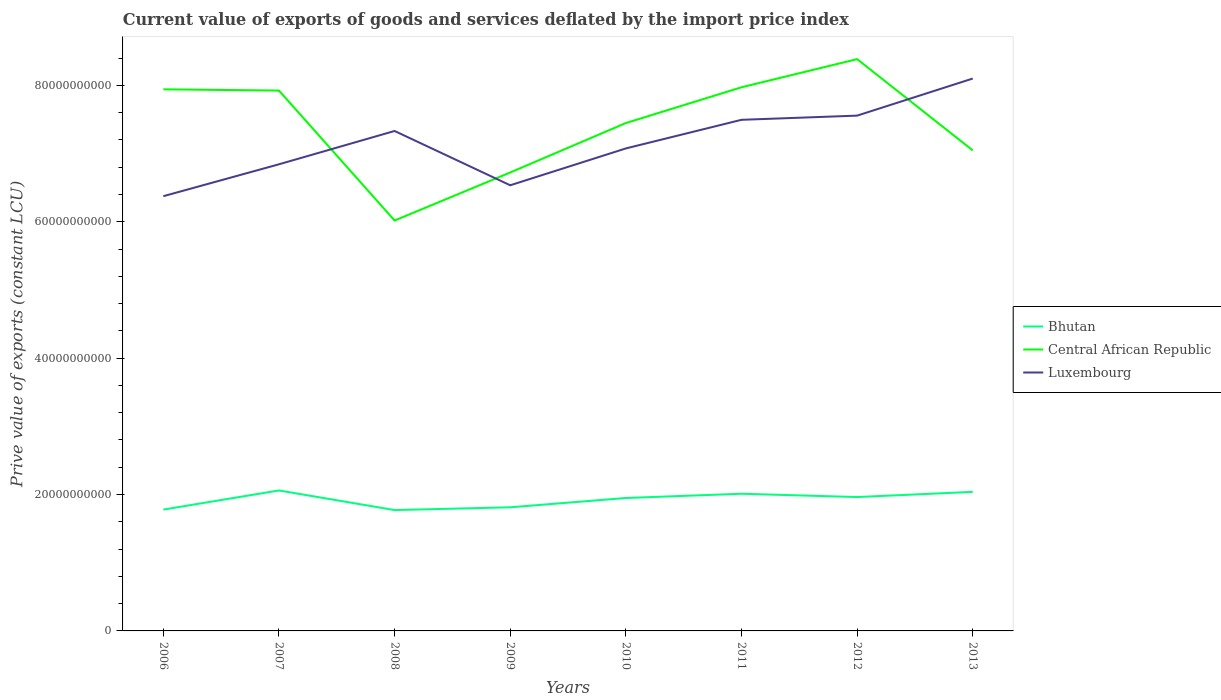How many different coloured lines are there?
Ensure brevity in your answer.  3. Does the line corresponding to Luxembourg intersect with the line corresponding to Bhutan?
Your answer should be very brief. No. Is the number of lines equal to the number of legend labels?
Provide a succinct answer. Yes. Across all years, what is the maximum prive value of exports in Bhutan?
Your response must be concise. 1.77e+1. In which year was the prive value of exports in Bhutan maximum?
Offer a terse response. 2008. What is the total prive value of exports in Central African Republic in the graph?
Ensure brevity in your answer.  -9.37e+09. What is the difference between the highest and the second highest prive value of exports in Bhutan?
Ensure brevity in your answer.  2.88e+09. What is the difference between the highest and the lowest prive value of exports in Bhutan?
Keep it short and to the point. 5. How many years are there in the graph?
Your answer should be very brief. 8. Are the values on the major ticks of Y-axis written in scientific E-notation?
Offer a very short reply. No. Does the graph contain any zero values?
Offer a terse response. No. Where does the legend appear in the graph?
Your answer should be compact. Center right. How many legend labels are there?
Keep it short and to the point. 3. What is the title of the graph?
Your answer should be very brief. Current value of exports of goods and services deflated by the import price index. What is the label or title of the X-axis?
Your answer should be very brief. Years. What is the label or title of the Y-axis?
Keep it short and to the point. Prive value of exports (constant LCU). What is the Prive value of exports (constant LCU) in Bhutan in 2006?
Provide a short and direct response. 1.78e+1. What is the Prive value of exports (constant LCU) of Central African Republic in 2006?
Provide a succinct answer. 7.94e+1. What is the Prive value of exports (constant LCU) in Luxembourg in 2006?
Your answer should be very brief. 6.37e+1. What is the Prive value of exports (constant LCU) of Bhutan in 2007?
Your answer should be compact. 2.06e+1. What is the Prive value of exports (constant LCU) in Central African Republic in 2007?
Make the answer very short. 7.92e+1. What is the Prive value of exports (constant LCU) of Luxembourg in 2007?
Your response must be concise. 6.84e+1. What is the Prive value of exports (constant LCU) in Bhutan in 2008?
Your answer should be compact. 1.77e+1. What is the Prive value of exports (constant LCU) of Central African Republic in 2008?
Keep it short and to the point. 6.02e+1. What is the Prive value of exports (constant LCU) of Luxembourg in 2008?
Your answer should be compact. 7.33e+1. What is the Prive value of exports (constant LCU) in Bhutan in 2009?
Give a very brief answer. 1.81e+1. What is the Prive value of exports (constant LCU) in Central African Republic in 2009?
Your answer should be compact. 6.72e+1. What is the Prive value of exports (constant LCU) in Luxembourg in 2009?
Your answer should be very brief. 6.54e+1. What is the Prive value of exports (constant LCU) of Bhutan in 2010?
Offer a terse response. 1.95e+1. What is the Prive value of exports (constant LCU) in Central African Republic in 2010?
Provide a short and direct response. 7.45e+1. What is the Prive value of exports (constant LCU) of Luxembourg in 2010?
Provide a succinct answer. 7.08e+1. What is the Prive value of exports (constant LCU) of Bhutan in 2011?
Your answer should be very brief. 2.01e+1. What is the Prive value of exports (constant LCU) of Central African Republic in 2011?
Keep it short and to the point. 7.97e+1. What is the Prive value of exports (constant LCU) of Luxembourg in 2011?
Make the answer very short. 7.50e+1. What is the Prive value of exports (constant LCU) in Bhutan in 2012?
Your answer should be very brief. 1.96e+1. What is the Prive value of exports (constant LCU) in Central African Republic in 2012?
Your answer should be compact. 8.39e+1. What is the Prive value of exports (constant LCU) in Luxembourg in 2012?
Your response must be concise. 7.56e+1. What is the Prive value of exports (constant LCU) of Bhutan in 2013?
Provide a short and direct response. 2.04e+1. What is the Prive value of exports (constant LCU) of Central African Republic in 2013?
Make the answer very short. 7.05e+1. What is the Prive value of exports (constant LCU) in Luxembourg in 2013?
Make the answer very short. 8.10e+1. Across all years, what is the maximum Prive value of exports (constant LCU) of Bhutan?
Provide a short and direct response. 2.06e+1. Across all years, what is the maximum Prive value of exports (constant LCU) in Central African Republic?
Offer a very short reply. 8.39e+1. Across all years, what is the maximum Prive value of exports (constant LCU) of Luxembourg?
Your answer should be very brief. 8.10e+1. Across all years, what is the minimum Prive value of exports (constant LCU) of Bhutan?
Your answer should be very brief. 1.77e+1. Across all years, what is the minimum Prive value of exports (constant LCU) of Central African Republic?
Your answer should be very brief. 6.02e+1. Across all years, what is the minimum Prive value of exports (constant LCU) of Luxembourg?
Make the answer very short. 6.37e+1. What is the total Prive value of exports (constant LCU) in Bhutan in the graph?
Offer a terse response. 1.54e+11. What is the total Prive value of exports (constant LCU) in Central African Republic in the graph?
Offer a terse response. 5.95e+11. What is the total Prive value of exports (constant LCU) in Luxembourg in the graph?
Ensure brevity in your answer.  5.73e+11. What is the difference between the Prive value of exports (constant LCU) of Bhutan in 2006 and that in 2007?
Make the answer very short. -2.81e+09. What is the difference between the Prive value of exports (constant LCU) in Central African Republic in 2006 and that in 2007?
Offer a terse response. 1.82e+08. What is the difference between the Prive value of exports (constant LCU) of Luxembourg in 2006 and that in 2007?
Make the answer very short. -4.68e+09. What is the difference between the Prive value of exports (constant LCU) in Bhutan in 2006 and that in 2008?
Offer a terse response. 7.04e+07. What is the difference between the Prive value of exports (constant LCU) of Central African Republic in 2006 and that in 2008?
Your answer should be compact. 1.92e+1. What is the difference between the Prive value of exports (constant LCU) of Luxembourg in 2006 and that in 2008?
Give a very brief answer. -9.56e+09. What is the difference between the Prive value of exports (constant LCU) of Bhutan in 2006 and that in 2009?
Offer a terse response. -3.35e+08. What is the difference between the Prive value of exports (constant LCU) in Central African Republic in 2006 and that in 2009?
Give a very brief answer. 1.22e+1. What is the difference between the Prive value of exports (constant LCU) in Luxembourg in 2006 and that in 2009?
Offer a very short reply. -1.60e+09. What is the difference between the Prive value of exports (constant LCU) of Bhutan in 2006 and that in 2010?
Your answer should be compact. -1.70e+09. What is the difference between the Prive value of exports (constant LCU) of Central African Republic in 2006 and that in 2010?
Ensure brevity in your answer.  4.94e+09. What is the difference between the Prive value of exports (constant LCU) in Luxembourg in 2006 and that in 2010?
Provide a short and direct response. -7.01e+09. What is the difference between the Prive value of exports (constant LCU) of Bhutan in 2006 and that in 2011?
Make the answer very short. -2.32e+09. What is the difference between the Prive value of exports (constant LCU) in Central African Republic in 2006 and that in 2011?
Make the answer very short. -3.00e+08. What is the difference between the Prive value of exports (constant LCU) of Luxembourg in 2006 and that in 2011?
Provide a succinct answer. -1.12e+1. What is the difference between the Prive value of exports (constant LCU) of Bhutan in 2006 and that in 2012?
Make the answer very short. -1.84e+09. What is the difference between the Prive value of exports (constant LCU) of Central African Republic in 2006 and that in 2012?
Provide a short and direct response. -4.43e+09. What is the difference between the Prive value of exports (constant LCU) in Luxembourg in 2006 and that in 2012?
Your answer should be very brief. -1.18e+1. What is the difference between the Prive value of exports (constant LCU) of Bhutan in 2006 and that in 2013?
Your response must be concise. -2.60e+09. What is the difference between the Prive value of exports (constant LCU) of Central African Republic in 2006 and that in 2013?
Make the answer very short. 8.95e+09. What is the difference between the Prive value of exports (constant LCU) of Luxembourg in 2006 and that in 2013?
Your response must be concise. -1.73e+1. What is the difference between the Prive value of exports (constant LCU) of Bhutan in 2007 and that in 2008?
Ensure brevity in your answer.  2.88e+09. What is the difference between the Prive value of exports (constant LCU) in Central African Republic in 2007 and that in 2008?
Ensure brevity in your answer.  1.91e+1. What is the difference between the Prive value of exports (constant LCU) of Luxembourg in 2007 and that in 2008?
Ensure brevity in your answer.  -4.89e+09. What is the difference between the Prive value of exports (constant LCU) in Bhutan in 2007 and that in 2009?
Your response must be concise. 2.47e+09. What is the difference between the Prive value of exports (constant LCU) in Central African Republic in 2007 and that in 2009?
Offer a very short reply. 1.20e+1. What is the difference between the Prive value of exports (constant LCU) in Luxembourg in 2007 and that in 2009?
Keep it short and to the point. 3.07e+09. What is the difference between the Prive value of exports (constant LCU) of Bhutan in 2007 and that in 2010?
Give a very brief answer. 1.11e+09. What is the difference between the Prive value of exports (constant LCU) in Central African Republic in 2007 and that in 2010?
Give a very brief answer. 4.76e+09. What is the difference between the Prive value of exports (constant LCU) of Luxembourg in 2007 and that in 2010?
Offer a terse response. -2.33e+09. What is the difference between the Prive value of exports (constant LCU) of Bhutan in 2007 and that in 2011?
Your answer should be very brief. 4.83e+08. What is the difference between the Prive value of exports (constant LCU) in Central African Republic in 2007 and that in 2011?
Offer a very short reply. -4.83e+08. What is the difference between the Prive value of exports (constant LCU) of Luxembourg in 2007 and that in 2011?
Provide a succinct answer. -6.52e+09. What is the difference between the Prive value of exports (constant LCU) in Bhutan in 2007 and that in 2012?
Offer a very short reply. 9.67e+08. What is the difference between the Prive value of exports (constant LCU) of Central African Republic in 2007 and that in 2012?
Offer a very short reply. -4.61e+09. What is the difference between the Prive value of exports (constant LCU) in Luxembourg in 2007 and that in 2012?
Offer a very short reply. -7.14e+09. What is the difference between the Prive value of exports (constant LCU) in Bhutan in 2007 and that in 2013?
Your answer should be very brief. 2.06e+08. What is the difference between the Prive value of exports (constant LCU) of Central African Republic in 2007 and that in 2013?
Offer a terse response. 8.77e+09. What is the difference between the Prive value of exports (constant LCU) of Luxembourg in 2007 and that in 2013?
Provide a succinct answer. -1.26e+1. What is the difference between the Prive value of exports (constant LCU) in Bhutan in 2008 and that in 2009?
Your answer should be very brief. -4.05e+08. What is the difference between the Prive value of exports (constant LCU) in Central African Republic in 2008 and that in 2009?
Offer a very short reply. -7.05e+09. What is the difference between the Prive value of exports (constant LCU) of Luxembourg in 2008 and that in 2009?
Your answer should be compact. 7.96e+09. What is the difference between the Prive value of exports (constant LCU) of Bhutan in 2008 and that in 2010?
Keep it short and to the point. -1.77e+09. What is the difference between the Prive value of exports (constant LCU) of Central African Republic in 2008 and that in 2010?
Give a very brief answer. -1.43e+1. What is the difference between the Prive value of exports (constant LCU) in Luxembourg in 2008 and that in 2010?
Make the answer very short. 2.56e+09. What is the difference between the Prive value of exports (constant LCU) of Bhutan in 2008 and that in 2011?
Provide a succinct answer. -2.39e+09. What is the difference between the Prive value of exports (constant LCU) of Central African Republic in 2008 and that in 2011?
Your answer should be compact. -1.95e+1. What is the difference between the Prive value of exports (constant LCU) of Luxembourg in 2008 and that in 2011?
Make the answer very short. -1.64e+09. What is the difference between the Prive value of exports (constant LCU) of Bhutan in 2008 and that in 2012?
Your answer should be very brief. -1.91e+09. What is the difference between the Prive value of exports (constant LCU) of Central African Republic in 2008 and that in 2012?
Provide a succinct answer. -2.37e+1. What is the difference between the Prive value of exports (constant LCU) of Luxembourg in 2008 and that in 2012?
Ensure brevity in your answer.  -2.25e+09. What is the difference between the Prive value of exports (constant LCU) of Bhutan in 2008 and that in 2013?
Offer a very short reply. -2.67e+09. What is the difference between the Prive value of exports (constant LCU) of Central African Republic in 2008 and that in 2013?
Make the answer very short. -1.03e+1. What is the difference between the Prive value of exports (constant LCU) in Luxembourg in 2008 and that in 2013?
Offer a very short reply. -7.69e+09. What is the difference between the Prive value of exports (constant LCU) in Bhutan in 2009 and that in 2010?
Your response must be concise. -1.36e+09. What is the difference between the Prive value of exports (constant LCU) in Central African Republic in 2009 and that in 2010?
Offer a terse response. -7.25e+09. What is the difference between the Prive value of exports (constant LCU) of Luxembourg in 2009 and that in 2010?
Your answer should be compact. -5.40e+09. What is the difference between the Prive value of exports (constant LCU) in Bhutan in 2009 and that in 2011?
Offer a terse response. -1.99e+09. What is the difference between the Prive value of exports (constant LCU) of Central African Republic in 2009 and that in 2011?
Provide a succinct answer. -1.25e+1. What is the difference between the Prive value of exports (constant LCU) of Luxembourg in 2009 and that in 2011?
Your answer should be compact. -9.60e+09. What is the difference between the Prive value of exports (constant LCU) of Bhutan in 2009 and that in 2012?
Provide a succinct answer. -1.50e+09. What is the difference between the Prive value of exports (constant LCU) of Central African Republic in 2009 and that in 2012?
Offer a terse response. -1.66e+1. What is the difference between the Prive value of exports (constant LCU) in Luxembourg in 2009 and that in 2012?
Keep it short and to the point. -1.02e+1. What is the difference between the Prive value of exports (constant LCU) in Bhutan in 2009 and that in 2013?
Offer a terse response. -2.26e+09. What is the difference between the Prive value of exports (constant LCU) in Central African Republic in 2009 and that in 2013?
Give a very brief answer. -3.24e+09. What is the difference between the Prive value of exports (constant LCU) in Luxembourg in 2009 and that in 2013?
Your response must be concise. -1.56e+1. What is the difference between the Prive value of exports (constant LCU) in Bhutan in 2010 and that in 2011?
Provide a short and direct response. -6.25e+08. What is the difference between the Prive value of exports (constant LCU) in Central African Republic in 2010 and that in 2011?
Provide a short and direct response. -5.24e+09. What is the difference between the Prive value of exports (constant LCU) of Luxembourg in 2010 and that in 2011?
Your response must be concise. -4.20e+09. What is the difference between the Prive value of exports (constant LCU) in Bhutan in 2010 and that in 2012?
Provide a short and direct response. -1.41e+08. What is the difference between the Prive value of exports (constant LCU) of Central African Republic in 2010 and that in 2012?
Offer a terse response. -9.37e+09. What is the difference between the Prive value of exports (constant LCU) in Luxembourg in 2010 and that in 2012?
Your answer should be very brief. -4.81e+09. What is the difference between the Prive value of exports (constant LCU) in Bhutan in 2010 and that in 2013?
Ensure brevity in your answer.  -9.02e+08. What is the difference between the Prive value of exports (constant LCU) of Central African Republic in 2010 and that in 2013?
Give a very brief answer. 4.01e+09. What is the difference between the Prive value of exports (constant LCU) of Luxembourg in 2010 and that in 2013?
Your response must be concise. -1.02e+1. What is the difference between the Prive value of exports (constant LCU) in Bhutan in 2011 and that in 2012?
Offer a terse response. 4.83e+08. What is the difference between the Prive value of exports (constant LCU) of Central African Republic in 2011 and that in 2012?
Ensure brevity in your answer.  -4.13e+09. What is the difference between the Prive value of exports (constant LCU) in Luxembourg in 2011 and that in 2012?
Provide a short and direct response. -6.13e+08. What is the difference between the Prive value of exports (constant LCU) in Bhutan in 2011 and that in 2013?
Your answer should be very brief. -2.77e+08. What is the difference between the Prive value of exports (constant LCU) of Central African Republic in 2011 and that in 2013?
Provide a short and direct response. 9.25e+09. What is the difference between the Prive value of exports (constant LCU) of Luxembourg in 2011 and that in 2013?
Provide a succinct answer. -6.05e+09. What is the difference between the Prive value of exports (constant LCU) in Bhutan in 2012 and that in 2013?
Make the answer very short. -7.60e+08. What is the difference between the Prive value of exports (constant LCU) of Central African Republic in 2012 and that in 2013?
Provide a succinct answer. 1.34e+1. What is the difference between the Prive value of exports (constant LCU) of Luxembourg in 2012 and that in 2013?
Offer a terse response. -5.44e+09. What is the difference between the Prive value of exports (constant LCU) of Bhutan in 2006 and the Prive value of exports (constant LCU) of Central African Republic in 2007?
Provide a short and direct response. -6.14e+1. What is the difference between the Prive value of exports (constant LCU) in Bhutan in 2006 and the Prive value of exports (constant LCU) in Luxembourg in 2007?
Your answer should be compact. -5.06e+1. What is the difference between the Prive value of exports (constant LCU) in Central African Republic in 2006 and the Prive value of exports (constant LCU) in Luxembourg in 2007?
Make the answer very short. 1.10e+1. What is the difference between the Prive value of exports (constant LCU) of Bhutan in 2006 and the Prive value of exports (constant LCU) of Central African Republic in 2008?
Your answer should be compact. -4.24e+1. What is the difference between the Prive value of exports (constant LCU) of Bhutan in 2006 and the Prive value of exports (constant LCU) of Luxembourg in 2008?
Provide a succinct answer. -5.55e+1. What is the difference between the Prive value of exports (constant LCU) in Central African Republic in 2006 and the Prive value of exports (constant LCU) in Luxembourg in 2008?
Ensure brevity in your answer.  6.11e+09. What is the difference between the Prive value of exports (constant LCU) in Bhutan in 2006 and the Prive value of exports (constant LCU) in Central African Republic in 2009?
Offer a terse response. -4.94e+1. What is the difference between the Prive value of exports (constant LCU) of Bhutan in 2006 and the Prive value of exports (constant LCU) of Luxembourg in 2009?
Make the answer very short. -4.76e+1. What is the difference between the Prive value of exports (constant LCU) of Central African Republic in 2006 and the Prive value of exports (constant LCU) of Luxembourg in 2009?
Your answer should be compact. 1.41e+1. What is the difference between the Prive value of exports (constant LCU) of Bhutan in 2006 and the Prive value of exports (constant LCU) of Central African Republic in 2010?
Make the answer very short. -5.67e+1. What is the difference between the Prive value of exports (constant LCU) in Bhutan in 2006 and the Prive value of exports (constant LCU) in Luxembourg in 2010?
Keep it short and to the point. -5.30e+1. What is the difference between the Prive value of exports (constant LCU) in Central African Republic in 2006 and the Prive value of exports (constant LCU) in Luxembourg in 2010?
Your answer should be compact. 8.67e+09. What is the difference between the Prive value of exports (constant LCU) in Bhutan in 2006 and the Prive value of exports (constant LCU) in Central African Republic in 2011?
Give a very brief answer. -6.19e+1. What is the difference between the Prive value of exports (constant LCU) of Bhutan in 2006 and the Prive value of exports (constant LCU) of Luxembourg in 2011?
Your answer should be compact. -5.72e+1. What is the difference between the Prive value of exports (constant LCU) in Central African Republic in 2006 and the Prive value of exports (constant LCU) in Luxembourg in 2011?
Your response must be concise. 4.47e+09. What is the difference between the Prive value of exports (constant LCU) in Bhutan in 2006 and the Prive value of exports (constant LCU) in Central African Republic in 2012?
Provide a succinct answer. -6.61e+1. What is the difference between the Prive value of exports (constant LCU) in Bhutan in 2006 and the Prive value of exports (constant LCU) in Luxembourg in 2012?
Provide a short and direct response. -5.78e+1. What is the difference between the Prive value of exports (constant LCU) of Central African Republic in 2006 and the Prive value of exports (constant LCU) of Luxembourg in 2012?
Provide a succinct answer. 3.86e+09. What is the difference between the Prive value of exports (constant LCU) of Bhutan in 2006 and the Prive value of exports (constant LCU) of Central African Republic in 2013?
Offer a very short reply. -5.27e+1. What is the difference between the Prive value of exports (constant LCU) of Bhutan in 2006 and the Prive value of exports (constant LCU) of Luxembourg in 2013?
Your response must be concise. -6.32e+1. What is the difference between the Prive value of exports (constant LCU) of Central African Republic in 2006 and the Prive value of exports (constant LCU) of Luxembourg in 2013?
Your answer should be compact. -1.58e+09. What is the difference between the Prive value of exports (constant LCU) in Bhutan in 2007 and the Prive value of exports (constant LCU) in Central African Republic in 2008?
Offer a terse response. -3.96e+1. What is the difference between the Prive value of exports (constant LCU) of Bhutan in 2007 and the Prive value of exports (constant LCU) of Luxembourg in 2008?
Give a very brief answer. -5.27e+1. What is the difference between the Prive value of exports (constant LCU) in Central African Republic in 2007 and the Prive value of exports (constant LCU) in Luxembourg in 2008?
Make the answer very short. 5.93e+09. What is the difference between the Prive value of exports (constant LCU) of Bhutan in 2007 and the Prive value of exports (constant LCU) of Central African Republic in 2009?
Provide a succinct answer. -4.66e+1. What is the difference between the Prive value of exports (constant LCU) in Bhutan in 2007 and the Prive value of exports (constant LCU) in Luxembourg in 2009?
Offer a terse response. -4.48e+1. What is the difference between the Prive value of exports (constant LCU) of Central African Republic in 2007 and the Prive value of exports (constant LCU) of Luxembourg in 2009?
Make the answer very short. 1.39e+1. What is the difference between the Prive value of exports (constant LCU) in Bhutan in 2007 and the Prive value of exports (constant LCU) in Central African Republic in 2010?
Offer a very short reply. -5.39e+1. What is the difference between the Prive value of exports (constant LCU) in Bhutan in 2007 and the Prive value of exports (constant LCU) in Luxembourg in 2010?
Provide a short and direct response. -5.02e+1. What is the difference between the Prive value of exports (constant LCU) of Central African Republic in 2007 and the Prive value of exports (constant LCU) of Luxembourg in 2010?
Your response must be concise. 8.49e+09. What is the difference between the Prive value of exports (constant LCU) in Bhutan in 2007 and the Prive value of exports (constant LCU) in Central African Republic in 2011?
Give a very brief answer. -5.91e+1. What is the difference between the Prive value of exports (constant LCU) in Bhutan in 2007 and the Prive value of exports (constant LCU) in Luxembourg in 2011?
Offer a very short reply. -5.44e+1. What is the difference between the Prive value of exports (constant LCU) in Central African Republic in 2007 and the Prive value of exports (constant LCU) in Luxembourg in 2011?
Offer a terse response. 4.29e+09. What is the difference between the Prive value of exports (constant LCU) in Bhutan in 2007 and the Prive value of exports (constant LCU) in Central African Republic in 2012?
Provide a short and direct response. -6.33e+1. What is the difference between the Prive value of exports (constant LCU) of Bhutan in 2007 and the Prive value of exports (constant LCU) of Luxembourg in 2012?
Provide a short and direct response. -5.50e+1. What is the difference between the Prive value of exports (constant LCU) of Central African Republic in 2007 and the Prive value of exports (constant LCU) of Luxembourg in 2012?
Offer a terse response. 3.68e+09. What is the difference between the Prive value of exports (constant LCU) of Bhutan in 2007 and the Prive value of exports (constant LCU) of Central African Republic in 2013?
Your answer should be compact. -4.99e+1. What is the difference between the Prive value of exports (constant LCU) of Bhutan in 2007 and the Prive value of exports (constant LCU) of Luxembourg in 2013?
Your answer should be very brief. -6.04e+1. What is the difference between the Prive value of exports (constant LCU) in Central African Republic in 2007 and the Prive value of exports (constant LCU) in Luxembourg in 2013?
Provide a short and direct response. -1.76e+09. What is the difference between the Prive value of exports (constant LCU) of Bhutan in 2008 and the Prive value of exports (constant LCU) of Central African Republic in 2009?
Your response must be concise. -4.95e+1. What is the difference between the Prive value of exports (constant LCU) in Bhutan in 2008 and the Prive value of exports (constant LCU) in Luxembourg in 2009?
Provide a short and direct response. -4.76e+1. What is the difference between the Prive value of exports (constant LCU) of Central African Republic in 2008 and the Prive value of exports (constant LCU) of Luxembourg in 2009?
Ensure brevity in your answer.  -5.17e+09. What is the difference between the Prive value of exports (constant LCU) in Bhutan in 2008 and the Prive value of exports (constant LCU) in Central African Republic in 2010?
Provide a short and direct response. -5.68e+1. What is the difference between the Prive value of exports (constant LCU) in Bhutan in 2008 and the Prive value of exports (constant LCU) in Luxembourg in 2010?
Offer a terse response. -5.30e+1. What is the difference between the Prive value of exports (constant LCU) in Central African Republic in 2008 and the Prive value of exports (constant LCU) in Luxembourg in 2010?
Make the answer very short. -1.06e+1. What is the difference between the Prive value of exports (constant LCU) in Bhutan in 2008 and the Prive value of exports (constant LCU) in Central African Republic in 2011?
Your answer should be very brief. -6.20e+1. What is the difference between the Prive value of exports (constant LCU) in Bhutan in 2008 and the Prive value of exports (constant LCU) in Luxembourg in 2011?
Make the answer very short. -5.72e+1. What is the difference between the Prive value of exports (constant LCU) of Central African Republic in 2008 and the Prive value of exports (constant LCU) of Luxembourg in 2011?
Offer a very short reply. -1.48e+1. What is the difference between the Prive value of exports (constant LCU) in Bhutan in 2008 and the Prive value of exports (constant LCU) in Central African Republic in 2012?
Offer a terse response. -6.61e+1. What is the difference between the Prive value of exports (constant LCU) of Bhutan in 2008 and the Prive value of exports (constant LCU) of Luxembourg in 2012?
Give a very brief answer. -5.78e+1. What is the difference between the Prive value of exports (constant LCU) in Central African Republic in 2008 and the Prive value of exports (constant LCU) in Luxembourg in 2012?
Your answer should be very brief. -1.54e+1. What is the difference between the Prive value of exports (constant LCU) of Bhutan in 2008 and the Prive value of exports (constant LCU) of Central African Republic in 2013?
Offer a terse response. -5.27e+1. What is the difference between the Prive value of exports (constant LCU) in Bhutan in 2008 and the Prive value of exports (constant LCU) in Luxembourg in 2013?
Your answer should be compact. -6.33e+1. What is the difference between the Prive value of exports (constant LCU) in Central African Republic in 2008 and the Prive value of exports (constant LCU) in Luxembourg in 2013?
Your response must be concise. -2.08e+1. What is the difference between the Prive value of exports (constant LCU) of Bhutan in 2009 and the Prive value of exports (constant LCU) of Central African Republic in 2010?
Provide a succinct answer. -5.64e+1. What is the difference between the Prive value of exports (constant LCU) of Bhutan in 2009 and the Prive value of exports (constant LCU) of Luxembourg in 2010?
Offer a terse response. -5.26e+1. What is the difference between the Prive value of exports (constant LCU) in Central African Republic in 2009 and the Prive value of exports (constant LCU) in Luxembourg in 2010?
Your answer should be compact. -3.53e+09. What is the difference between the Prive value of exports (constant LCU) in Bhutan in 2009 and the Prive value of exports (constant LCU) in Central African Republic in 2011?
Make the answer very short. -6.16e+1. What is the difference between the Prive value of exports (constant LCU) in Bhutan in 2009 and the Prive value of exports (constant LCU) in Luxembourg in 2011?
Your answer should be very brief. -5.68e+1. What is the difference between the Prive value of exports (constant LCU) of Central African Republic in 2009 and the Prive value of exports (constant LCU) of Luxembourg in 2011?
Your answer should be very brief. -7.72e+09. What is the difference between the Prive value of exports (constant LCU) of Bhutan in 2009 and the Prive value of exports (constant LCU) of Central African Republic in 2012?
Your response must be concise. -6.57e+1. What is the difference between the Prive value of exports (constant LCU) of Bhutan in 2009 and the Prive value of exports (constant LCU) of Luxembourg in 2012?
Ensure brevity in your answer.  -5.74e+1. What is the difference between the Prive value of exports (constant LCU) of Central African Republic in 2009 and the Prive value of exports (constant LCU) of Luxembourg in 2012?
Your response must be concise. -8.34e+09. What is the difference between the Prive value of exports (constant LCU) of Bhutan in 2009 and the Prive value of exports (constant LCU) of Central African Republic in 2013?
Your answer should be very brief. -5.23e+1. What is the difference between the Prive value of exports (constant LCU) in Bhutan in 2009 and the Prive value of exports (constant LCU) in Luxembourg in 2013?
Provide a succinct answer. -6.29e+1. What is the difference between the Prive value of exports (constant LCU) in Central African Republic in 2009 and the Prive value of exports (constant LCU) in Luxembourg in 2013?
Keep it short and to the point. -1.38e+1. What is the difference between the Prive value of exports (constant LCU) in Bhutan in 2010 and the Prive value of exports (constant LCU) in Central African Republic in 2011?
Provide a succinct answer. -6.02e+1. What is the difference between the Prive value of exports (constant LCU) in Bhutan in 2010 and the Prive value of exports (constant LCU) in Luxembourg in 2011?
Your response must be concise. -5.55e+1. What is the difference between the Prive value of exports (constant LCU) of Central African Republic in 2010 and the Prive value of exports (constant LCU) of Luxembourg in 2011?
Keep it short and to the point. -4.73e+08. What is the difference between the Prive value of exports (constant LCU) in Bhutan in 2010 and the Prive value of exports (constant LCU) in Central African Republic in 2012?
Offer a very short reply. -6.44e+1. What is the difference between the Prive value of exports (constant LCU) in Bhutan in 2010 and the Prive value of exports (constant LCU) in Luxembourg in 2012?
Your answer should be very brief. -5.61e+1. What is the difference between the Prive value of exports (constant LCU) of Central African Republic in 2010 and the Prive value of exports (constant LCU) of Luxembourg in 2012?
Offer a very short reply. -1.09e+09. What is the difference between the Prive value of exports (constant LCU) of Bhutan in 2010 and the Prive value of exports (constant LCU) of Central African Republic in 2013?
Provide a succinct answer. -5.10e+1. What is the difference between the Prive value of exports (constant LCU) of Bhutan in 2010 and the Prive value of exports (constant LCU) of Luxembourg in 2013?
Ensure brevity in your answer.  -6.15e+1. What is the difference between the Prive value of exports (constant LCU) in Central African Republic in 2010 and the Prive value of exports (constant LCU) in Luxembourg in 2013?
Your answer should be compact. -6.52e+09. What is the difference between the Prive value of exports (constant LCU) in Bhutan in 2011 and the Prive value of exports (constant LCU) in Central African Republic in 2012?
Your answer should be very brief. -6.37e+1. What is the difference between the Prive value of exports (constant LCU) of Bhutan in 2011 and the Prive value of exports (constant LCU) of Luxembourg in 2012?
Offer a terse response. -5.54e+1. What is the difference between the Prive value of exports (constant LCU) of Central African Republic in 2011 and the Prive value of exports (constant LCU) of Luxembourg in 2012?
Give a very brief answer. 4.16e+09. What is the difference between the Prive value of exports (constant LCU) in Bhutan in 2011 and the Prive value of exports (constant LCU) in Central African Republic in 2013?
Ensure brevity in your answer.  -5.04e+1. What is the difference between the Prive value of exports (constant LCU) of Bhutan in 2011 and the Prive value of exports (constant LCU) of Luxembourg in 2013?
Your answer should be very brief. -6.09e+1. What is the difference between the Prive value of exports (constant LCU) of Central African Republic in 2011 and the Prive value of exports (constant LCU) of Luxembourg in 2013?
Give a very brief answer. -1.28e+09. What is the difference between the Prive value of exports (constant LCU) of Bhutan in 2012 and the Prive value of exports (constant LCU) of Central African Republic in 2013?
Your answer should be very brief. -5.08e+1. What is the difference between the Prive value of exports (constant LCU) in Bhutan in 2012 and the Prive value of exports (constant LCU) in Luxembourg in 2013?
Provide a short and direct response. -6.14e+1. What is the difference between the Prive value of exports (constant LCU) in Central African Republic in 2012 and the Prive value of exports (constant LCU) in Luxembourg in 2013?
Your answer should be very brief. 2.85e+09. What is the average Prive value of exports (constant LCU) of Bhutan per year?
Provide a succinct answer. 1.92e+1. What is the average Prive value of exports (constant LCU) of Central African Republic per year?
Provide a succinct answer. 7.43e+1. What is the average Prive value of exports (constant LCU) of Luxembourg per year?
Ensure brevity in your answer.  7.16e+1. In the year 2006, what is the difference between the Prive value of exports (constant LCU) in Bhutan and Prive value of exports (constant LCU) in Central African Republic?
Keep it short and to the point. -6.16e+1. In the year 2006, what is the difference between the Prive value of exports (constant LCU) in Bhutan and Prive value of exports (constant LCU) in Luxembourg?
Offer a terse response. -4.60e+1. In the year 2006, what is the difference between the Prive value of exports (constant LCU) in Central African Republic and Prive value of exports (constant LCU) in Luxembourg?
Make the answer very short. 1.57e+1. In the year 2007, what is the difference between the Prive value of exports (constant LCU) in Bhutan and Prive value of exports (constant LCU) in Central African Republic?
Provide a short and direct response. -5.86e+1. In the year 2007, what is the difference between the Prive value of exports (constant LCU) in Bhutan and Prive value of exports (constant LCU) in Luxembourg?
Ensure brevity in your answer.  -4.78e+1. In the year 2007, what is the difference between the Prive value of exports (constant LCU) of Central African Republic and Prive value of exports (constant LCU) of Luxembourg?
Your answer should be compact. 1.08e+1. In the year 2008, what is the difference between the Prive value of exports (constant LCU) of Bhutan and Prive value of exports (constant LCU) of Central African Republic?
Provide a short and direct response. -4.25e+1. In the year 2008, what is the difference between the Prive value of exports (constant LCU) of Bhutan and Prive value of exports (constant LCU) of Luxembourg?
Your answer should be very brief. -5.56e+1. In the year 2008, what is the difference between the Prive value of exports (constant LCU) of Central African Republic and Prive value of exports (constant LCU) of Luxembourg?
Make the answer very short. -1.31e+1. In the year 2009, what is the difference between the Prive value of exports (constant LCU) in Bhutan and Prive value of exports (constant LCU) in Central African Republic?
Provide a succinct answer. -4.91e+1. In the year 2009, what is the difference between the Prive value of exports (constant LCU) in Bhutan and Prive value of exports (constant LCU) in Luxembourg?
Make the answer very short. -4.72e+1. In the year 2009, what is the difference between the Prive value of exports (constant LCU) in Central African Republic and Prive value of exports (constant LCU) in Luxembourg?
Your response must be concise. 1.87e+09. In the year 2010, what is the difference between the Prive value of exports (constant LCU) in Bhutan and Prive value of exports (constant LCU) in Central African Republic?
Keep it short and to the point. -5.50e+1. In the year 2010, what is the difference between the Prive value of exports (constant LCU) in Bhutan and Prive value of exports (constant LCU) in Luxembourg?
Your answer should be very brief. -5.13e+1. In the year 2010, what is the difference between the Prive value of exports (constant LCU) in Central African Republic and Prive value of exports (constant LCU) in Luxembourg?
Provide a succinct answer. 3.72e+09. In the year 2011, what is the difference between the Prive value of exports (constant LCU) of Bhutan and Prive value of exports (constant LCU) of Central African Republic?
Your answer should be very brief. -5.96e+1. In the year 2011, what is the difference between the Prive value of exports (constant LCU) in Bhutan and Prive value of exports (constant LCU) in Luxembourg?
Keep it short and to the point. -5.48e+1. In the year 2011, what is the difference between the Prive value of exports (constant LCU) of Central African Republic and Prive value of exports (constant LCU) of Luxembourg?
Your answer should be very brief. 4.77e+09. In the year 2012, what is the difference between the Prive value of exports (constant LCU) of Bhutan and Prive value of exports (constant LCU) of Central African Republic?
Make the answer very short. -6.42e+1. In the year 2012, what is the difference between the Prive value of exports (constant LCU) of Bhutan and Prive value of exports (constant LCU) of Luxembourg?
Ensure brevity in your answer.  -5.59e+1. In the year 2012, what is the difference between the Prive value of exports (constant LCU) in Central African Republic and Prive value of exports (constant LCU) in Luxembourg?
Keep it short and to the point. 8.29e+09. In the year 2013, what is the difference between the Prive value of exports (constant LCU) in Bhutan and Prive value of exports (constant LCU) in Central African Republic?
Your answer should be compact. -5.01e+1. In the year 2013, what is the difference between the Prive value of exports (constant LCU) of Bhutan and Prive value of exports (constant LCU) of Luxembourg?
Offer a terse response. -6.06e+1. In the year 2013, what is the difference between the Prive value of exports (constant LCU) in Central African Republic and Prive value of exports (constant LCU) in Luxembourg?
Offer a terse response. -1.05e+1. What is the ratio of the Prive value of exports (constant LCU) in Bhutan in 2006 to that in 2007?
Your response must be concise. 0.86. What is the ratio of the Prive value of exports (constant LCU) of Central African Republic in 2006 to that in 2007?
Keep it short and to the point. 1. What is the ratio of the Prive value of exports (constant LCU) in Luxembourg in 2006 to that in 2007?
Ensure brevity in your answer.  0.93. What is the ratio of the Prive value of exports (constant LCU) of Central African Republic in 2006 to that in 2008?
Offer a very short reply. 1.32. What is the ratio of the Prive value of exports (constant LCU) in Luxembourg in 2006 to that in 2008?
Ensure brevity in your answer.  0.87. What is the ratio of the Prive value of exports (constant LCU) of Bhutan in 2006 to that in 2009?
Keep it short and to the point. 0.98. What is the ratio of the Prive value of exports (constant LCU) of Central African Republic in 2006 to that in 2009?
Provide a succinct answer. 1.18. What is the ratio of the Prive value of exports (constant LCU) of Luxembourg in 2006 to that in 2009?
Your answer should be very brief. 0.98. What is the ratio of the Prive value of exports (constant LCU) in Bhutan in 2006 to that in 2010?
Ensure brevity in your answer.  0.91. What is the ratio of the Prive value of exports (constant LCU) in Central African Republic in 2006 to that in 2010?
Keep it short and to the point. 1.07. What is the ratio of the Prive value of exports (constant LCU) of Luxembourg in 2006 to that in 2010?
Ensure brevity in your answer.  0.9. What is the ratio of the Prive value of exports (constant LCU) of Bhutan in 2006 to that in 2011?
Offer a very short reply. 0.88. What is the ratio of the Prive value of exports (constant LCU) of Luxembourg in 2006 to that in 2011?
Provide a short and direct response. 0.85. What is the ratio of the Prive value of exports (constant LCU) in Bhutan in 2006 to that in 2012?
Make the answer very short. 0.91. What is the ratio of the Prive value of exports (constant LCU) in Central African Republic in 2006 to that in 2012?
Your answer should be compact. 0.95. What is the ratio of the Prive value of exports (constant LCU) in Luxembourg in 2006 to that in 2012?
Make the answer very short. 0.84. What is the ratio of the Prive value of exports (constant LCU) in Bhutan in 2006 to that in 2013?
Provide a short and direct response. 0.87. What is the ratio of the Prive value of exports (constant LCU) in Central African Republic in 2006 to that in 2013?
Keep it short and to the point. 1.13. What is the ratio of the Prive value of exports (constant LCU) in Luxembourg in 2006 to that in 2013?
Keep it short and to the point. 0.79. What is the ratio of the Prive value of exports (constant LCU) of Bhutan in 2007 to that in 2008?
Provide a succinct answer. 1.16. What is the ratio of the Prive value of exports (constant LCU) of Central African Republic in 2007 to that in 2008?
Make the answer very short. 1.32. What is the ratio of the Prive value of exports (constant LCU) in Luxembourg in 2007 to that in 2008?
Give a very brief answer. 0.93. What is the ratio of the Prive value of exports (constant LCU) in Bhutan in 2007 to that in 2009?
Provide a succinct answer. 1.14. What is the ratio of the Prive value of exports (constant LCU) in Central African Republic in 2007 to that in 2009?
Provide a short and direct response. 1.18. What is the ratio of the Prive value of exports (constant LCU) of Luxembourg in 2007 to that in 2009?
Your answer should be very brief. 1.05. What is the ratio of the Prive value of exports (constant LCU) of Bhutan in 2007 to that in 2010?
Offer a very short reply. 1.06. What is the ratio of the Prive value of exports (constant LCU) of Central African Republic in 2007 to that in 2010?
Keep it short and to the point. 1.06. What is the ratio of the Prive value of exports (constant LCU) of Luxembourg in 2007 to that in 2010?
Keep it short and to the point. 0.97. What is the ratio of the Prive value of exports (constant LCU) of Luxembourg in 2007 to that in 2011?
Ensure brevity in your answer.  0.91. What is the ratio of the Prive value of exports (constant LCU) of Bhutan in 2007 to that in 2012?
Give a very brief answer. 1.05. What is the ratio of the Prive value of exports (constant LCU) in Central African Republic in 2007 to that in 2012?
Give a very brief answer. 0.94. What is the ratio of the Prive value of exports (constant LCU) in Luxembourg in 2007 to that in 2012?
Make the answer very short. 0.91. What is the ratio of the Prive value of exports (constant LCU) in Central African Republic in 2007 to that in 2013?
Offer a terse response. 1.12. What is the ratio of the Prive value of exports (constant LCU) of Luxembourg in 2007 to that in 2013?
Your response must be concise. 0.84. What is the ratio of the Prive value of exports (constant LCU) in Bhutan in 2008 to that in 2009?
Make the answer very short. 0.98. What is the ratio of the Prive value of exports (constant LCU) of Central African Republic in 2008 to that in 2009?
Give a very brief answer. 0.9. What is the ratio of the Prive value of exports (constant LCU) in Luxembourg in 2008 to that in 2009?
Offer a very short reply. 1.12. What is the ratio of the Prive value of exports (constant LCU) of Bhutan in 2008 to that in 2010?
Offer a very short reply. 0.91. What is the ratio of the Prive value of exports (constant LCU) of Central African Republic in 2008 to that in 2010?
Offer a terse response. 0.81. What is the ratio of the Prive value of exports (constant LCU) in Luxembourg in 2008 to that in 2010?
Ensure brevity in your answer.  1.04. What is the ratio of the Prive value of exports (constant LCU) of Bhutan in 2008 to that in 2011?
Ensure brevity in your answer.  0.88. What is the ratio of the Prive value of exports (constant LCU) in Central African Republic in 2008 to that in 2011?
Ensure brevity in your answer.  0.75. What is the ratio of the Prive value of exports (constant LCU) in Luxembourg in 2008 to that in 2011?
Your answer should be compact. 0.98. What is the ratio of the Prive value of exports (constant LCU) in Bhutan in 2008 to that in 2012?
Provide a short and direct response. 0.9. What is the ratio of the Prive value of exports (constant LCU) in Central African Republic in 2008 to that in 2012?
Provide a succinct answer. 0.72. What is the ratio of the Prive value of exports (constant LCU) in Luxembourg in 2008 to that in 2012?
Ensure brevity in your answer.  0.97. What is the ratio of the Prive value of exports (constant LCU) of Bhutan in 2008 to that in 2013?
Give a very brief answer. 0.87. What is the ratio of the Prive value of exports (constant LCU) in Central African Republic in 2008 to that in 2013?
Make the answer very short. 0.85. What is the ratio of the Prive value of exports (constant LCU) in Luxembourg in 2008 to that in 2013?
Your answer should be compact. 0.91. What is the ratio of the Prive value of exports (constant LCU) in Bhutan in 2009 to that in 2010?
Make the answer very short. 0.93. What is the ratio of the Prive value of exports (constant LCU) in Central African Republic in 2009 to that in 2010?
Make the answer very short. 0.9. What is the ratio of the Prive value of exports (constant LCU) of Luxembourg in 2009 to that in 2010?
Keep it short and to the point. 0.92. What is the ratio of the Prive value of exports (constant LCU) in Bhutan in 2009 to that in 2011?
Ensure brevity in your answer.  0.9. What is the ratio of the Prive value of exports (constant LCU) of Central African Republic in 2009 to that in 2011?
Your response must be concise. 0.84. What is the ratio of the Prive value of exports (constant LCU) of Luxembourg in 2009 to that in 2011?
Make the answer very short. 0.87. What is the ratio of the Prive value of exports (constant LCU) of Bhutan in 2009 to that in 2012?
Provide a succinct answer. 0.92. What is the ratio of the Prive value of exports (constant LCU) in Central African Republic in 2009 to that in 2012?
Keep it short and to the point. 0.8. What is the ratio of the Prive value of exports (constant LCU) of Luxembourg in 2009 to that in 2012?
Offer a terse response. 0.86. What is the ratio of the Prive value of exports (constant LCU) of Central African Republic in 2009 to that in 2013?
Make the answer very short. 0.95. What is the ratio of the Prive value of exports (constant LCU) in Luxembourg in 2009 to that in 2013?
Ensure brevity in your answer.  0.81. What is the ratio of the Prive value of exports (constant LCU) in Bhutan in 2010 to that in 2011?
Ensure brevity in your answer.  0.97. What is the ratio of the Prive value of exports (constant LCU) in Central African Republic in 2010 to that in 2011?
Ensure brevity in your answer.  0.93. What is the ratio of the Prive value of exports (constant LCU) of Luxembourg in 2010 to that in 2011?
Keep it short and to the point. 0.94. What is the ratio of the Prive value of exports (constant LCU) of Bhutan in 2010 to that in 2012?
Offer a very short reply. 0.99. What is the ratio of the Prive value of exports (constant LCU) in Central African Republic in 2010 to that in 2012?
Provide a succinct answer. 0.89. What is the ratio of the Prive value of exports (constant LCU) of Luxembourg in 2010 to that in 2012?
Your response must be concise. 0.94. What is the ratio of the Prive value of exports (constant LCU) of Bhutan in 2010 to that in 2013?
Provide a succinct answer. 0.96. What is the ratio of the Prive value of exports (constant LCU) in Central African Republic in 2010 to that in 2013?
Offer a very short reply. 1.06. What is the ratio of the Prive value of exports (constant LCU) in Luxembourg in 2010 to that in 2013?
Offer a terse response. 0.87. What is the ratio of the Prive value of exports (constant LCU) of Bhutan in 2011 to that in 2012?
Provide a short and direct response. 1.02. What is the ratio of the Prive value of exports (constant LCU) in Central African Republic in 2011 to that in 2012?
Give a very brief answer. 0.95. What is the ratio of the Prive value of exports (constant LCU) in Bhutan in 2011 to that in 2013?
Your answer should be very brief. 0.99. What is the ratio of the Prive value of exports (constant LCU) of Central African Republic in 2011 to that in 2013?
Provide a short and direct response. 1.13. What is the ratio of the Prive value of exports (constant LCU) of Luxembourg in 2011 to that in 2013?
Your answer should be compact. 0.93. What is the ratio of the Prive value of exports (constant LCU) in Bhutan in 2012 to that in 2013?
Provide a short and direct response. 0.96. What is the ratio of the Prive value of exports (constant LCU) in Central African Republic in 2012 to that in 2013?
Offer a very short reply. 1.19. What is the ratio of the Prive value of exports (constant LCU) in Luxembourg in 2012 to that in 2013?
Ensure brevity in your answer.  0.93. What is the difference between the highest and the second highest Prive value of exports (constant LCU) in Bhutan?
Provide a short and direct response. 2.06e+08. What is the difference between the highest and the second highest Prive value of exports (constant LCU) of Central African Republic?
Offer a very short reply. 4.13e+09. What is the difference between the highest and the second highest Prive value of exports (constant LCU) of Luxembourg?
Keep it short and to the point. 5.44e+09. What is the difference between the highest and the lowest Prive value of exports (constant LCU) of Bhutan?
Your answer should be very brief. 2.88e+09. What is the difference between the highest and the lowest Prive value of exports (constant LCU) of Central African Republic?
Keep it short and to the point. 2.37e+1. What is the difference between the highest and the lowest Prive value of exports (constant LCU) in Luxembourg?
Ensure brevity in your answer.  1.73e+1. 